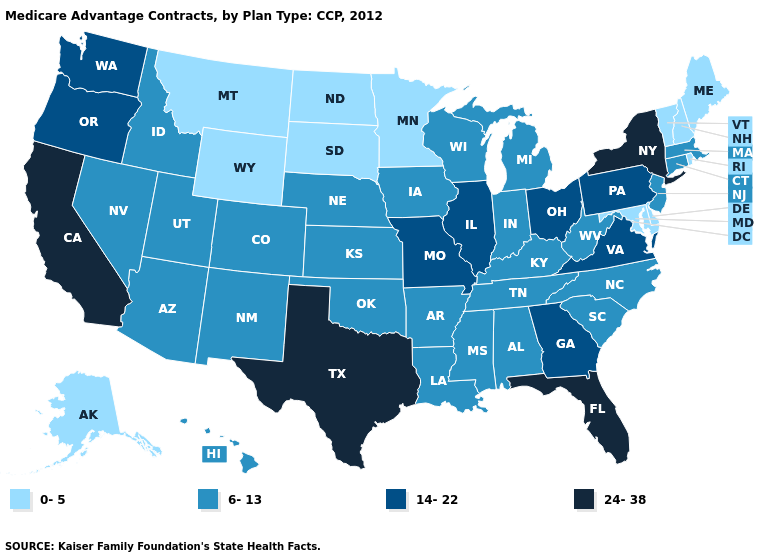What is the value of Michigan?
Keep it brief. 6-13. Name the states that have a value in the range 14-22?
Concise answer only. Georgia, Illinois, Missouri, Ohio, Oregon, Pennsylvania, Virginia, Washington. Name the states that have a value in the range 6-13?
Be succinct. Alabama, Arkansas, Arizona, Colorado, Connecticut, Hawaii, Iowa, Idaho, Indiana, Kansas, Kentucky, Louisiana, Massachusetts, Michigan, Mississippi, North Carolina, Nebraska, New Jersey, New Mexico, Nevada, Oklahoma, South Carolina, Tennessee, Utah, Wisconsin, West Virginia. Does West Virginia have a higher value than Oklahoma?
Be succinct. No. Does Tennessee have the lowest value in the South?
Write a very short answer. No. Among the states that border Virginia , which have the highest value?
Give a very brief answer. Kentucky, North Carolina, Tennessee, West Virginia. What is the highest value in the USA?
Answer briefly. 24-38. What is the lowest value in states that border West Virginia?
Concise answer only. 0-5. Does Texas have a higher value than Florida?
Answer briefly. No. What is the lowest value in states that border Pennsylvania?
Answer briefly. 0-5. Does the first symbol in the legend represent the smallest category?
Quick response, please. Yes. What is the value of Pennsylvania?
Keep it brief. 14-22. Name the states that have a value in the range 0-5?
Write a very short answer. Alaska, Delaware, Maryland, Maine, Minnesota, Montana, North Dakota, New Hampshire, Rhode Island, South Dakota, Vermont, Wyoming. What is the value of Maryland?
Short answer required. 0-5. 